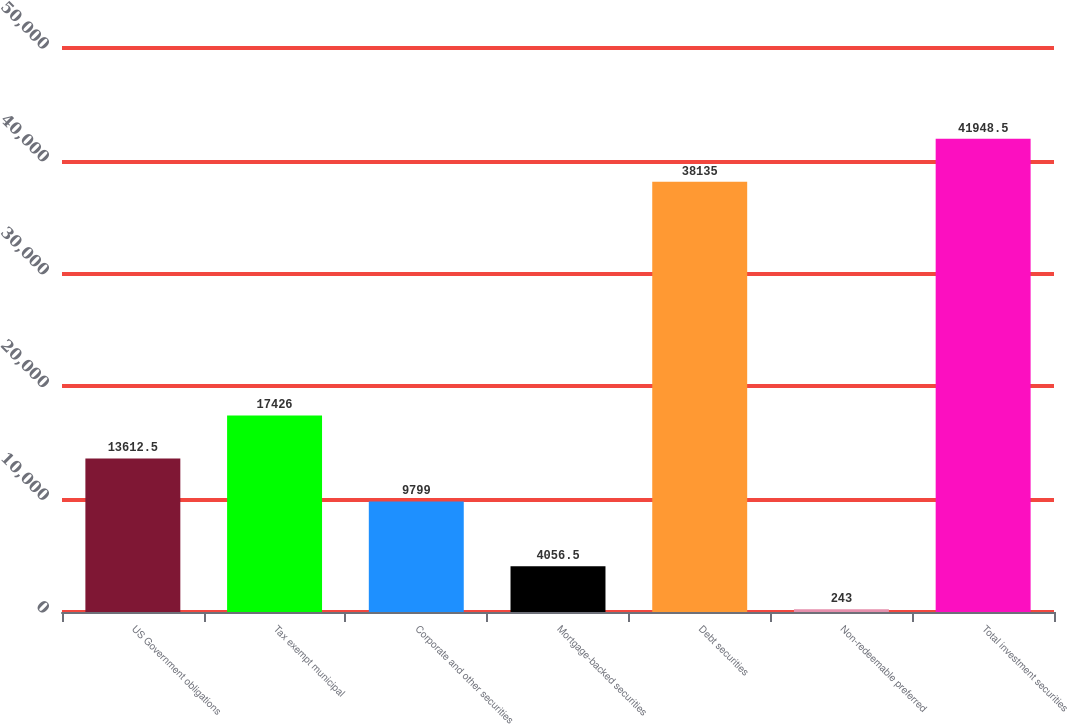Convert chart. <chart><loc_0><loc_0><loc_500><loc_500><bar_chart><fcel>US Government obligations<fcel>Tax exempt municipal<fcel>Corporate and other securities<fcel>Mortgage-backed securities<fcel>Debt securities<fcel>Non-redeemable preferred<fcel>Total investment securities<nl><fcel>13612.5<fcel>17426<fcel>9799<fcel>4056.5<fcel>38135<fcel>243<fcel>41948.5<nl></chart> 